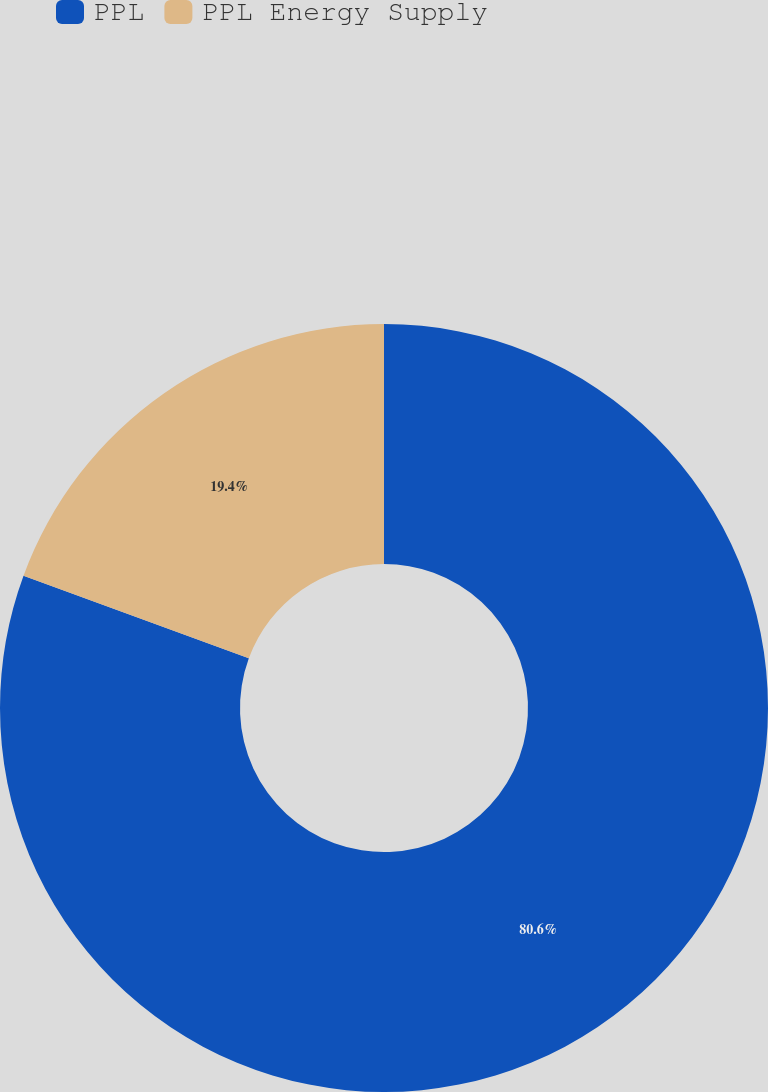<chart> <loc_0><loc_0><loc_500><loc_500><pie_chart><fcel>PPL<fcel>PPL Energy Supply<nl><fcel>80.6%<fcel>19.4%<nl></chart> 